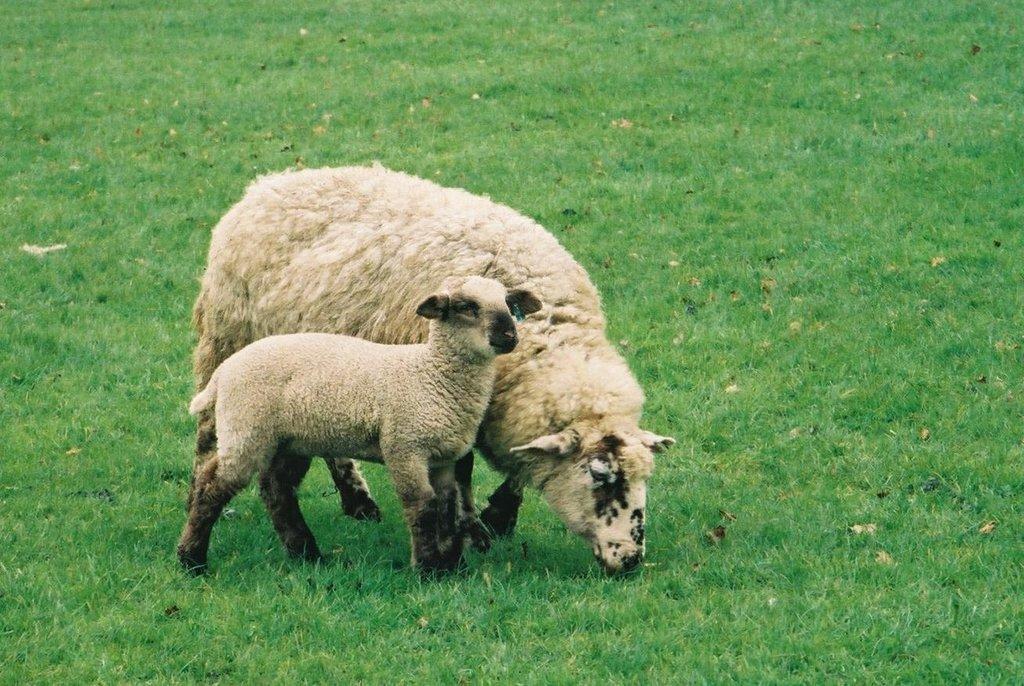In one or two sentences, can you explain what this image depicts? In this image there are two sheeps standing on the surface of the grass. 